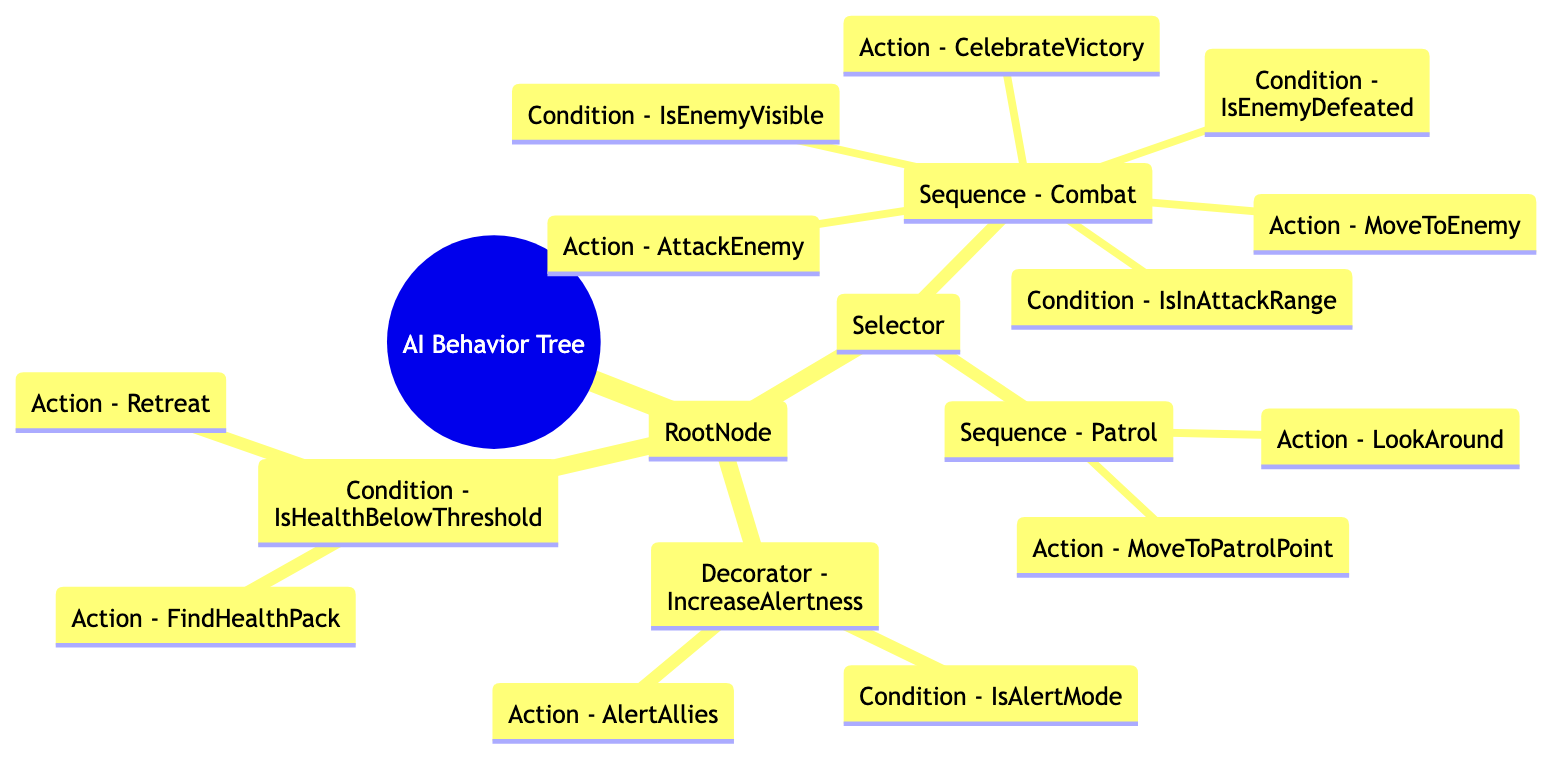What is the root node of the AI behavior tree? The diagram shows that the root node is labeled as "RootNode". This can be found at the top of the hierarchy as the first child of the main node representing the AI behavior tree.
Answer: RootNode How many children does the Selector node have? In the diagram, the Selector node has two children: "Sequence - Combat" and "Sequence - Patrol". This can be counted directly from the list of child nodes under the Selector node.
Answer: 2 What action is performed if the condition "IsHealthBelowThreshold" is true? Following the diagram, when the condition "IsHealthBelowThreshold" is true, the actions "Retreat" and "FindHealthPack" are the next steps. Both actions are children of this condition.
Answer: Retreat, FindHealthPack What type of node is "Action - MoveToEnemy"? The diagram categorizes "Action - MoveToEnemy" as an ActionNode. By analyzing the structure, it is seen that this node is a child of the "Sequence - Combat", which is a ControlNode.
Answer: ActionNode In which sequence does the condition "IsEnemyDefeated" appear? Looking at the structure outlined in the diagram, "IsEnemyDefeated" appears in the "Sequence - Combat". This node follows a series of actions and conditions related to combat behavior.
Answer: Sequence - Combat What happens if the "IsAlertMode" condition is true? The diagram indicates that if "IsAlertMode" is true, the action "AlertAllies" is performed, as it is a child under the "Decorator - IncreaseAlertness" that directly follows this condition.
Answer: AlertAllies What is the final action in the combat sequence? By examining the combat sequence in the diagram, the final action after checking the conditions is "CelebrateVictory", which is the last action node listed under "Sequence - Combat".
Answer: CelebrateVictory What type of node is "Decorator - IncreaseAlertness"? "Decorator - IncreaseAlertness" is categorized as a DecoratorNode according to the diagram. This can be seen from its classification as a node that alters the behavior of its child nodes based on specific conditions.
Answer: DecoratorNode How many action nodes are present in the root node? In total, the root node contains five action nodes: "MoveToEnemy", "AttackEnemy", "CelebrateVictory", "MoveToPatrolPoint", and "LookAround". This can be summed up by reviewing each sequence and condition for their action children.
Answer: 5 